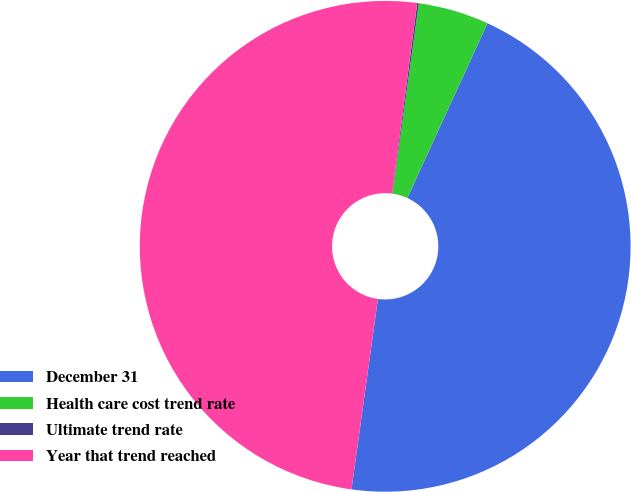Convert chart to OTSL. <chart><loc_0><loc_0><loc_500><loc_500><pie_chart><fcel>December 31<fcel>Health care cost trend rate<fcel>Ultimate trend rate<fcel>Year that trend reached<nl><fcel>45.35%<fcel>4.65%<fcel>0.11%<fcel>49.89%<nl></chart> 